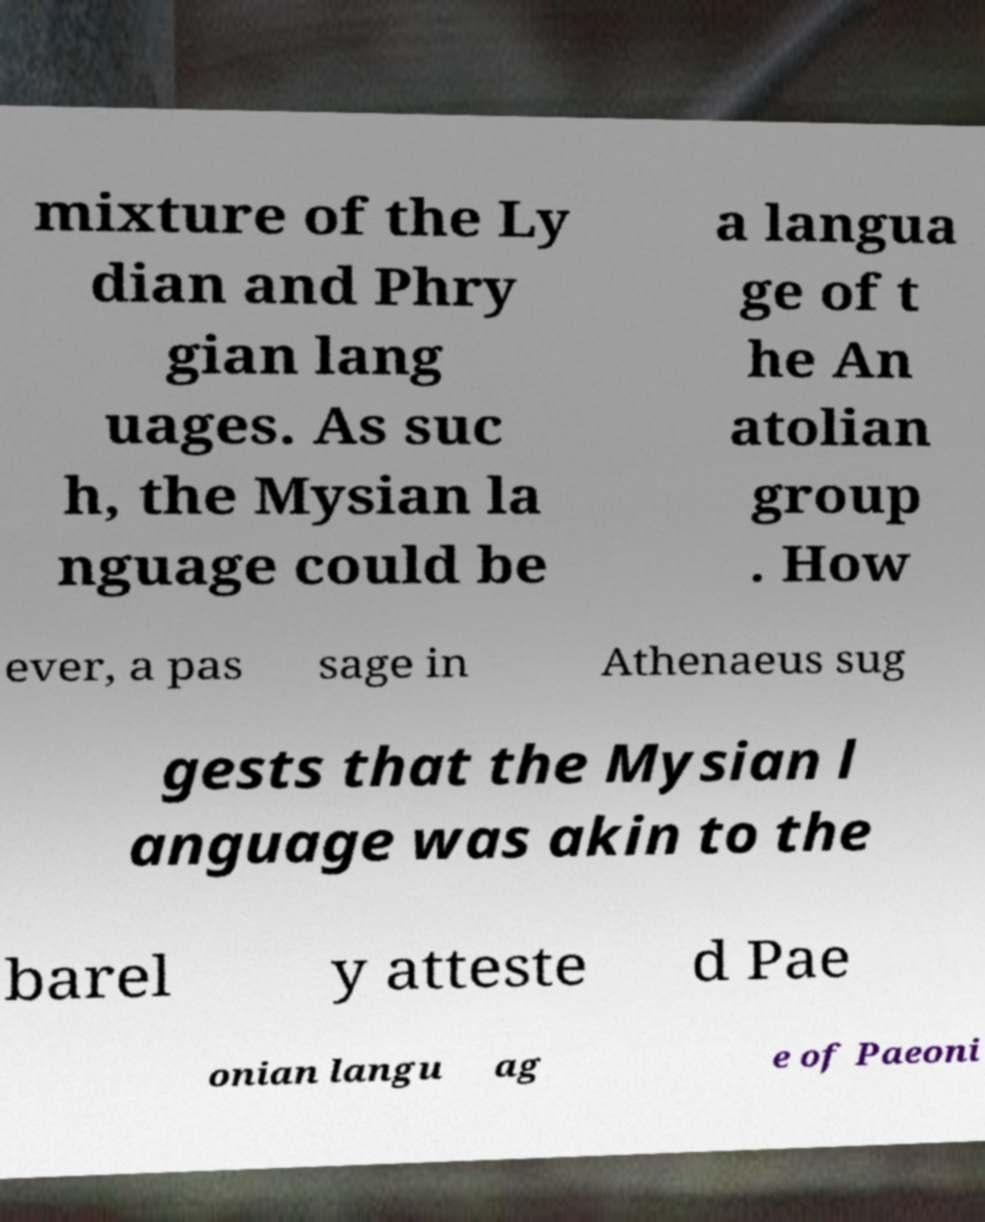Could you assist in decoding the text presented in this image and type it out clearly? mixture of the Ly dian and Phry gian lang uages. As suc h, the Mysian la nguage could be a langua ge of t he An atolian group . How ever, a pas sage in Athenaeus sug gests that the Mysian l anguage was akin to the barel y atteste d Pae onian langu ag e of Paeoni 